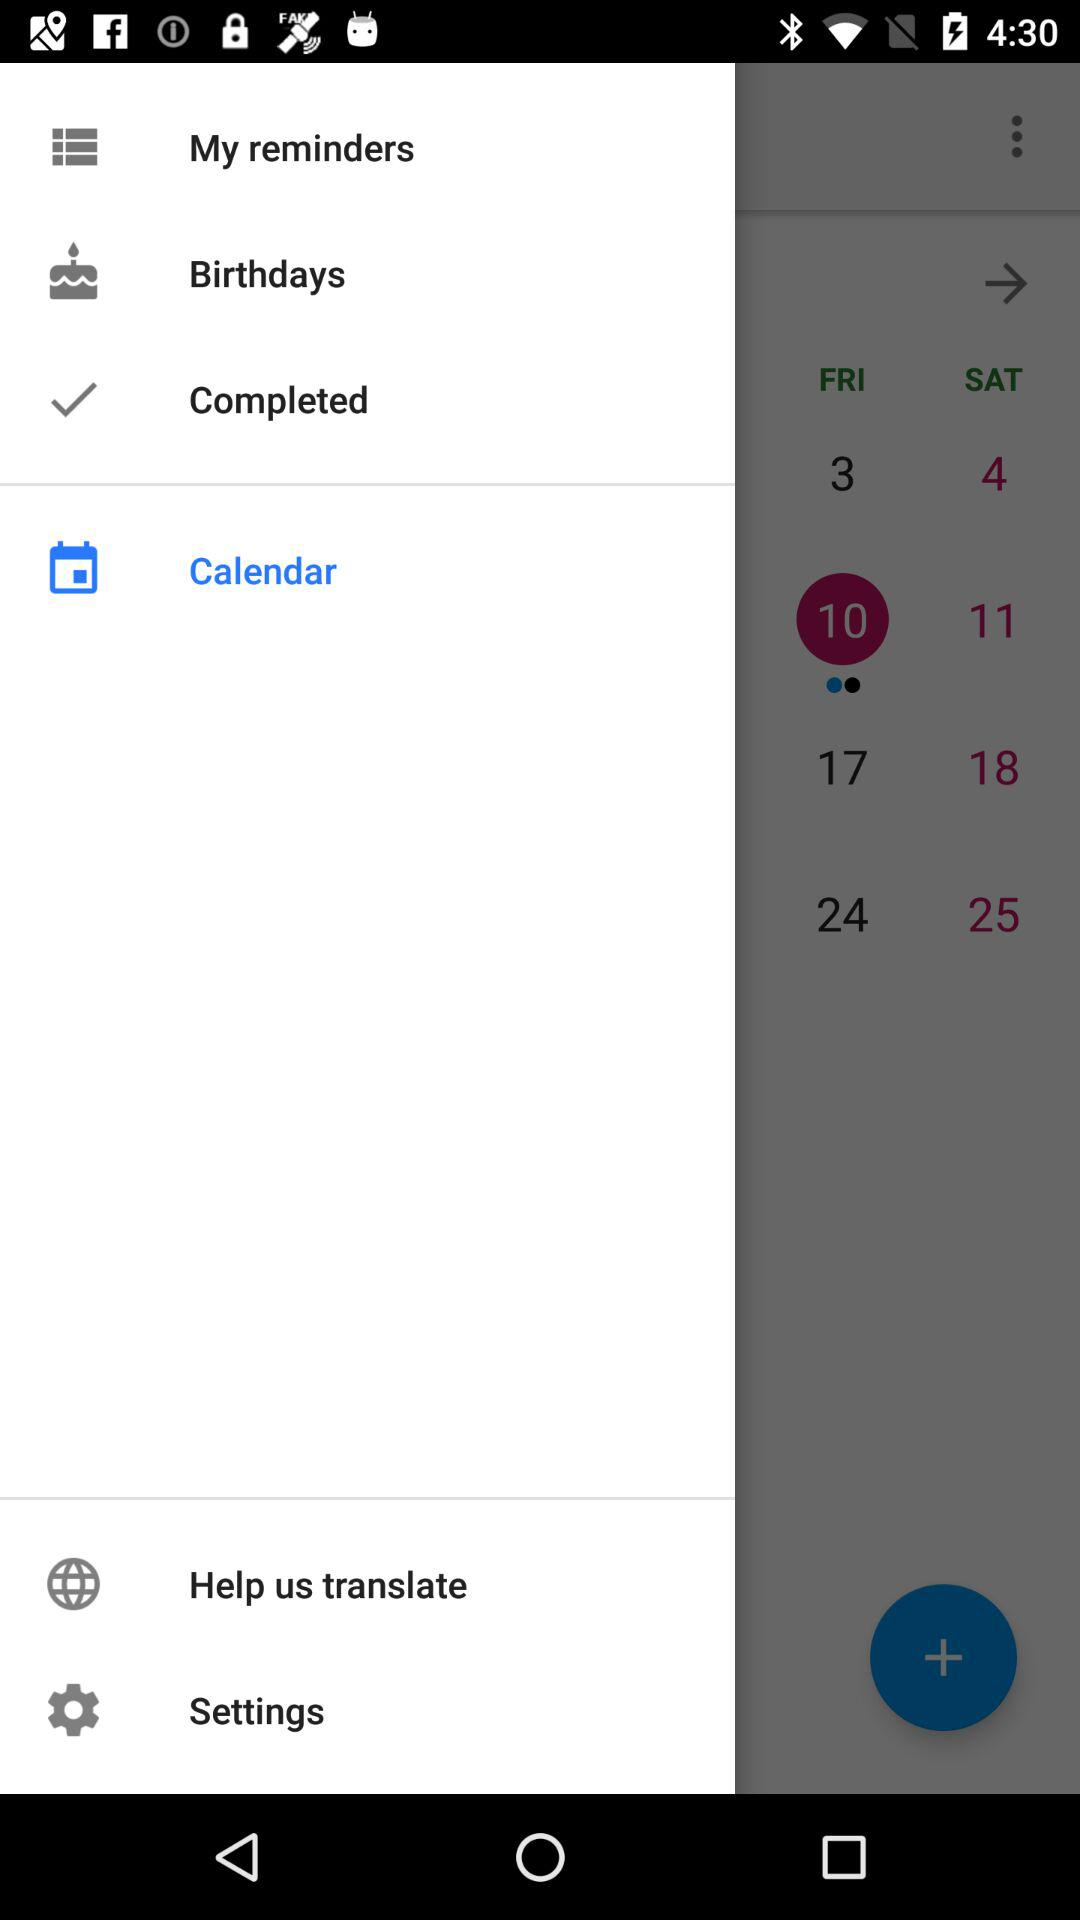Which date is selected? The selected date is 10. 